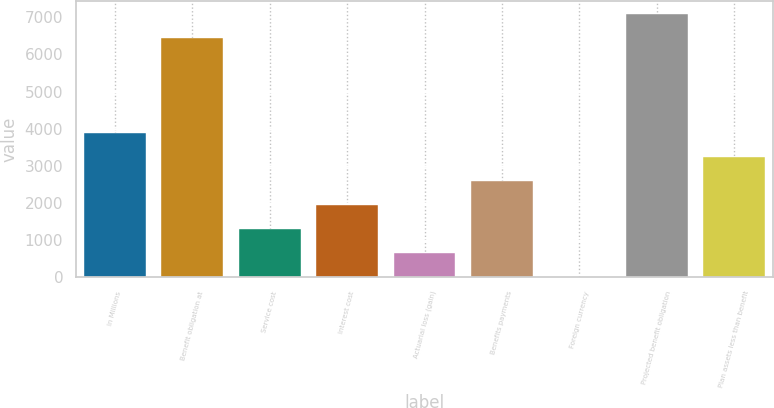Convert chart. <chart><loc_0><loc_0><loc_500><loc_500><bar_chart><fcel>In Millions<fcel>Benefit obligation at<fcel>Service cost<fcel>Interest cost<fcel>Actuarial loss (gain)<fcel>Benefits payments<fcel>Foreign currency<fcel>Projected benefit obligation<fcel>Plan assets less than benefit<nl><fcel>3879.88<fcel>6448.5<fcel>1301.16<fcel>1945.84<fcel>656.48<fcel>2590.52<fcel>11.8<fcel>7093.18<fcel>3235.2<nl></chart> 